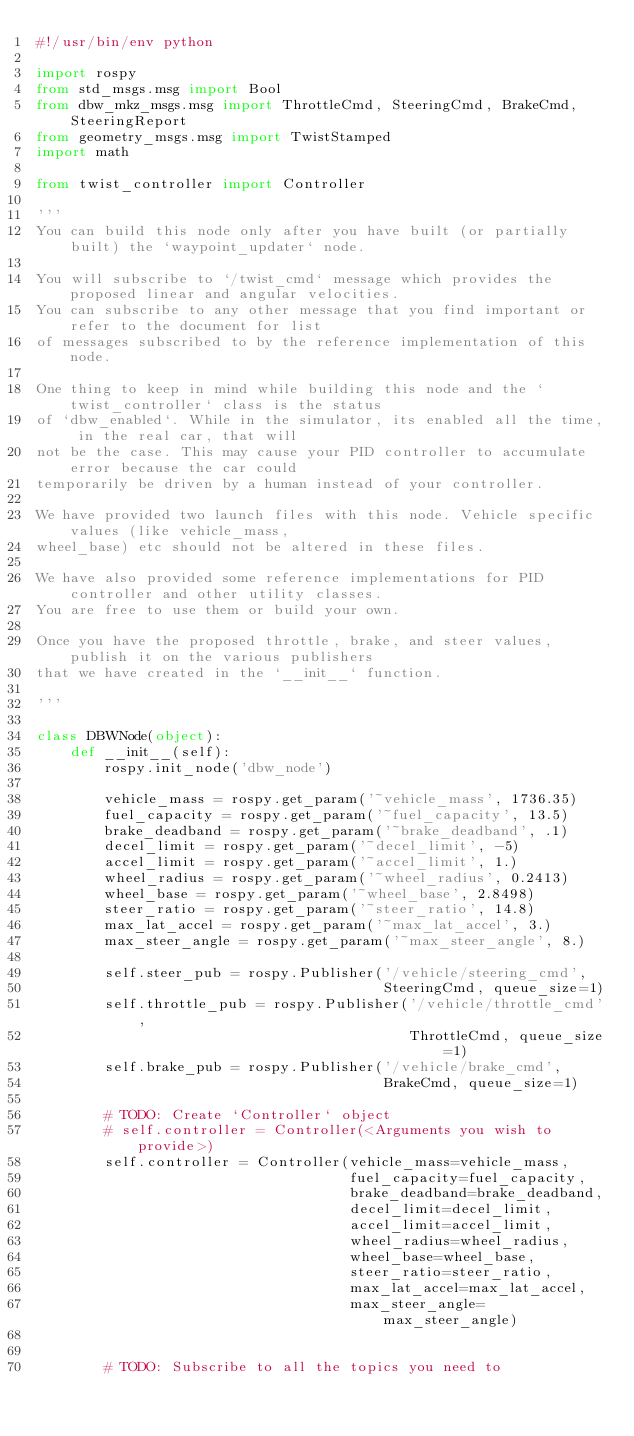Convert code to text. <code><loc_0><loc_0><loc_500><loc_500><_Python_>#!/usr/bin/env python

import rospy
from std_msgs.msg import Bool
from dbw_mkz_msgs.msg import ThrottleCmd, SteeringCmd, BrakeCmd, SteeringReport
from geometry_msgs.msg import TwistStamped
import math

from twist_controller import Controller

'''
You can build this node only after you have built (or partially built) the `waypoint_updater` node.

You will subscribe to `/twist_cmd` message which provides the proposed linear and angular velocities.
You can subscribe to any other message that you find important or refer to the document for list
of messages subscribed to by the reference implementation of this node.

One thing to keep in mind while building this node and the `twist_controller` class is the status
of `dbw_enabled`. While in the simulator, its enabled all the time, in the real car, that will
not be the case. This may cause your PID controller to accumulate error because the car could
temporarily be driven by a human instead of your controller.

We have provided two launch files with this node. Vehicle specific values (like vehicle_mass,
wheel_base) etc should not be altered in these files.

We have also provided some reference implementations for PID controller and other utility classes.
You are free to use them or build your own.

Once you have the proposed throttle, brake, and steer values, publish it on the various publishers
that we have created in the `__init__` function.

'''

class DBWNode(object):
    def __init__(self):
        rospy.init_node('dbw_node')

        vehicle_mass = rospy.get_param('~vehicle_mass', 1736.35)
        fuel_capacity = rospy.get_param('~fuel_capacity', 13.5)
        brake_deadband = rospy.get_param('~brake_deadband', .1)
        decel_limit = rospy.get_param('~decel_limit', -5)
        accel_limit = rospy.get_param('~accel_limit', 1.)
        wheel_radius = rospy.get_param('~wheel_radius', 0.2413)
        wheel_base = rospy.get_param('~wheel_base', 2.8498)
        steer_ratio = rospy.get_param('~steer_ratio', 14.8)
        max_lat_accel = rospy.get_param('~max_lat_accel', 3.)
        max_steer_angle = rospy.get_param('~max_steer_angle', 8.)

        self.steer_pub = rospy.Publisher('/vehicle/steering_cmd',
                                         SteeringCmd, queue_size=1)
        self.throttle_pub = rospy.Publisher('/vehicle/throttle_cmd',
                                            ThrottleCmd, queue_size=1)
        self.brake_pub = rospy.Publisher('/vehicle/brake_cmd',
                                         BrakeCmd, queue_size=1)

        # TODO: Create `Controller` object
        # self.controller = Controller(<Arguments you wish to provide>)
        self.controller = Controller(vehicle_mass=vehicle_mass,
                                     fuel_capacity=fuel_capacity,
                                     brake_deadband=brake_deadband,
                                     decel_limit=decel_limit,
                                     accel_limit=accel_limit,
                                     wheel_radius=wheel_radius,
                                     wheel_base=wheel_base,
                                     steer_ratio=steer_ratio,
                                     max_lat_accel=max_lat_accel,
                                     max_steer_angle=max_steer_angle)


        # TODO: Subscribe to all the topics you need to</code> 